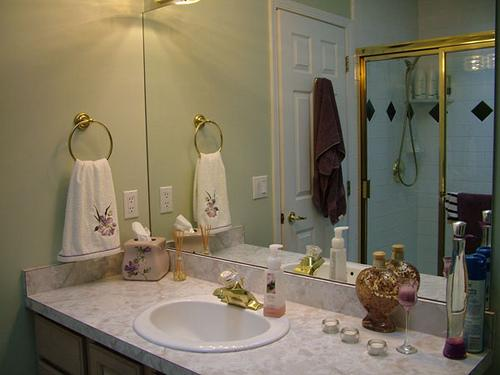What is closest to the place you would go to charge your phone?

Choices:
A) white towel
B) tissues
C) candle
D) red towel white towel 